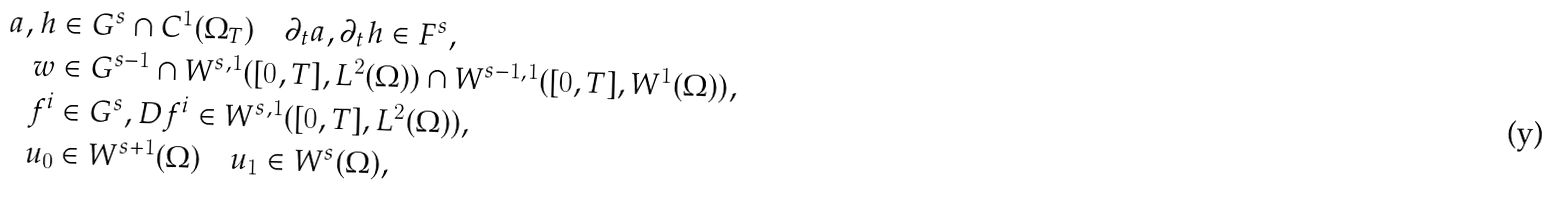Convert formula to latex. <formula><loc_0><loc_0><loc_500><loc_500>a , h & \in G ^ { s } \cap C ^ { 1 } ( \Omega _ { T } ) \quad \partial _ { t } a , \partial _ { t } h \in F ^ { s } , \\ w & \in G ^ { s - 1 } \cap W ^ { s , 1 } ( [ 0 , T ] , L ^ { 2 } ( \Omega ) ) \cap W ^ { s - 1 , 1 } ( [ 0 , T ] , W ^ { 1 } ( \Omega ) ) , \\ f ^ { i } & \in G ^ { s } , D f ^ { i } \in W ^ { s , 1 } ( [ 0 , T ] , L ^ { 2 } ( \Omega ) ) , \\ u _ { 0 } & \in W ^ { s + 1 } ( \Omega ) \quad u _ { 1 } \in W ^ { s } ( \Omega ) ,</formula> 